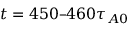Convert formula to latex. <formula><loc_0><loc_0><loc_500><loc_500>t = 4 5 0 4 6 0 \tau _ { A 0 }</formula> 